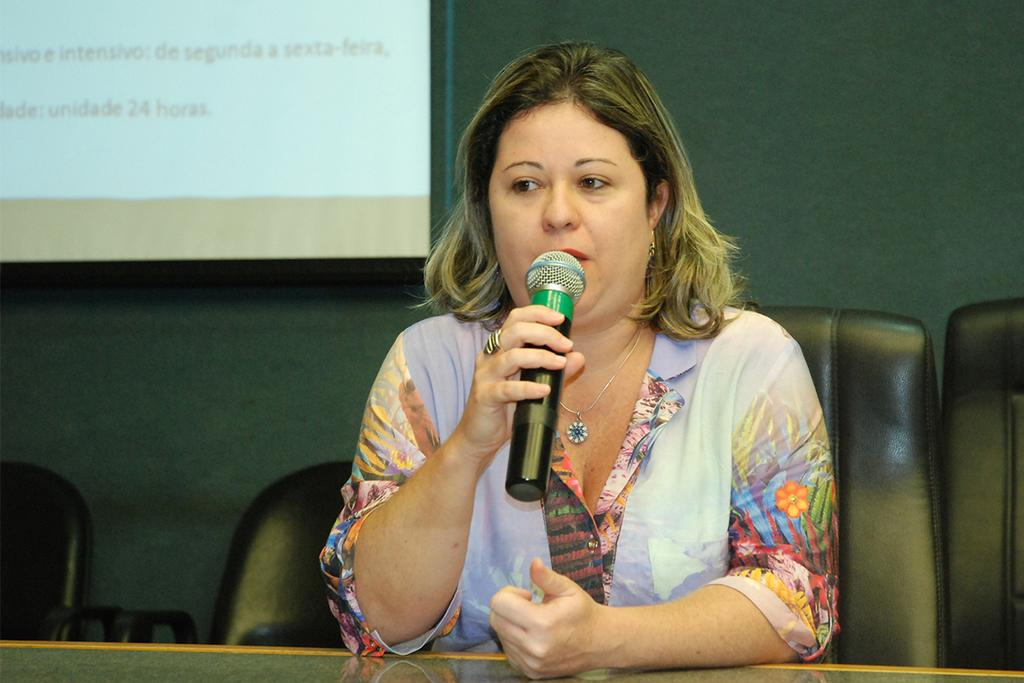Who is the main subject in the image? There is a woman in the image. What is the woman doing in the image? The woman is sitting on a sofa and speaking on a microphone. What can be seen in the background of the image? There is a screen visible in the background of the image. How many bears are visible on the edge of the screen in the image? There are no bears present in the image, and the edge of the screen cannot be seen in the provided facts. 